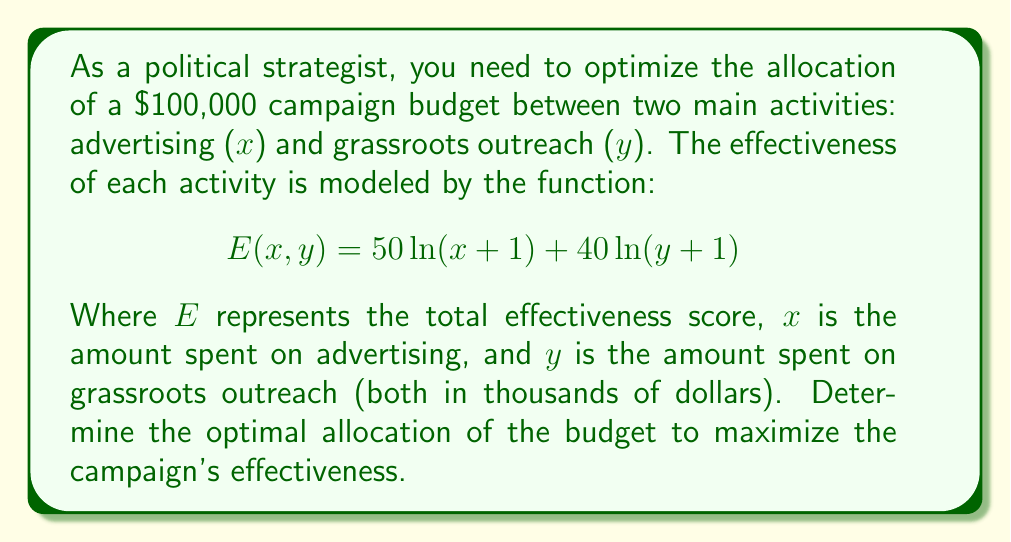Give your solution to this math problem. To solve this optimization problem, we'll use the method of Lagrange multipliers:

1) Define the constraint equation:
   $$g(x,y) = x + y - 100 = 0$$

2) Form the Lagrangian function:
   $$L(x,y,\lambda) = 50\ln(x+1) + 40\ln(y+1) - \lambda(x + y - 100)$$

3) Take partial derivatives and set them equal to zero:
   $$\frac{\partial L}{\partial x} = \frac{50}{x+1} - \lambda = 0$$
   $$\frac{\partial L}{\partial y} = \frac{40}{y+1} - \lambda = 0$$
   $$\frac{\partial L}{\partial \lambda} = x + y - 100 = 0$$

4) From the first two equations:
   $$\frac{50}{x+1} = \frac{40}{y+1}$$

5) Cross multiply:
   $$50(y+1) = 40(x+1)$$
   $$50y + 50 = 40x + 40$$
   $$50y - 40x = -10$$
   $$5y - 4x = -1$$

6) Substitute this into the constraint equation:
   $$x + (\frac{4x-1}{5}) = 100$$
   $$5x + 4x - 1 = 500$$
   $$9x = 501$$
   $$x = 55.67$$

7) Solve for y:
   $$y = 100 - 55.67 = 44.33$$

8) Round to the nearest thousand dollars:
   x ≈ $56,000 (advertising)
   y ≈ $44,000 (grassroots outreach)
Answer: Advertising: $56,000, Grassroots outreach: $44,000 